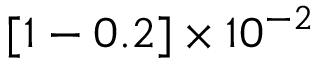<formula> <loc_0><loc_0><loc_500><loc_500>[ 1 - 0 . 2 ] \times 1 0 ^ { - 2 }</formula> 